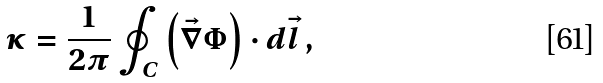<formula> <loc_0><loc_0><loc_500><loc_500>\kappa = \frac { 1 } { 2 \pi } \oint _ { C } \left ( \vec { \nabla } \Phi \right ) \cdot d \vec { l } \, ,</formula> 